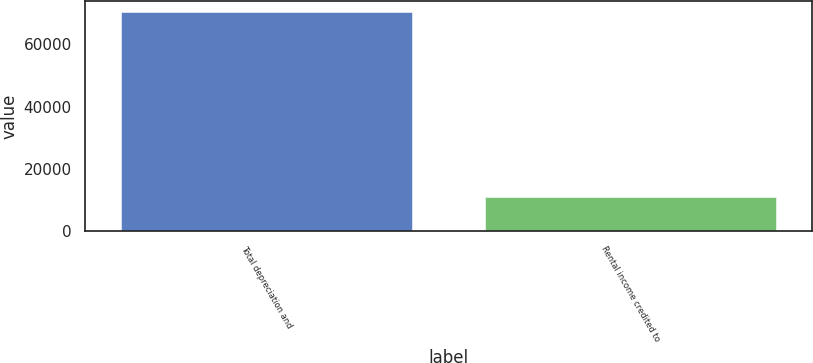<chart> <loc_0><loc_0><loc_500><loc_500><bar_chart><fcel>Total depreciation and<fcel>Rental income credited to<nl><fcel>70413<fcel>10878<nl></chart> 